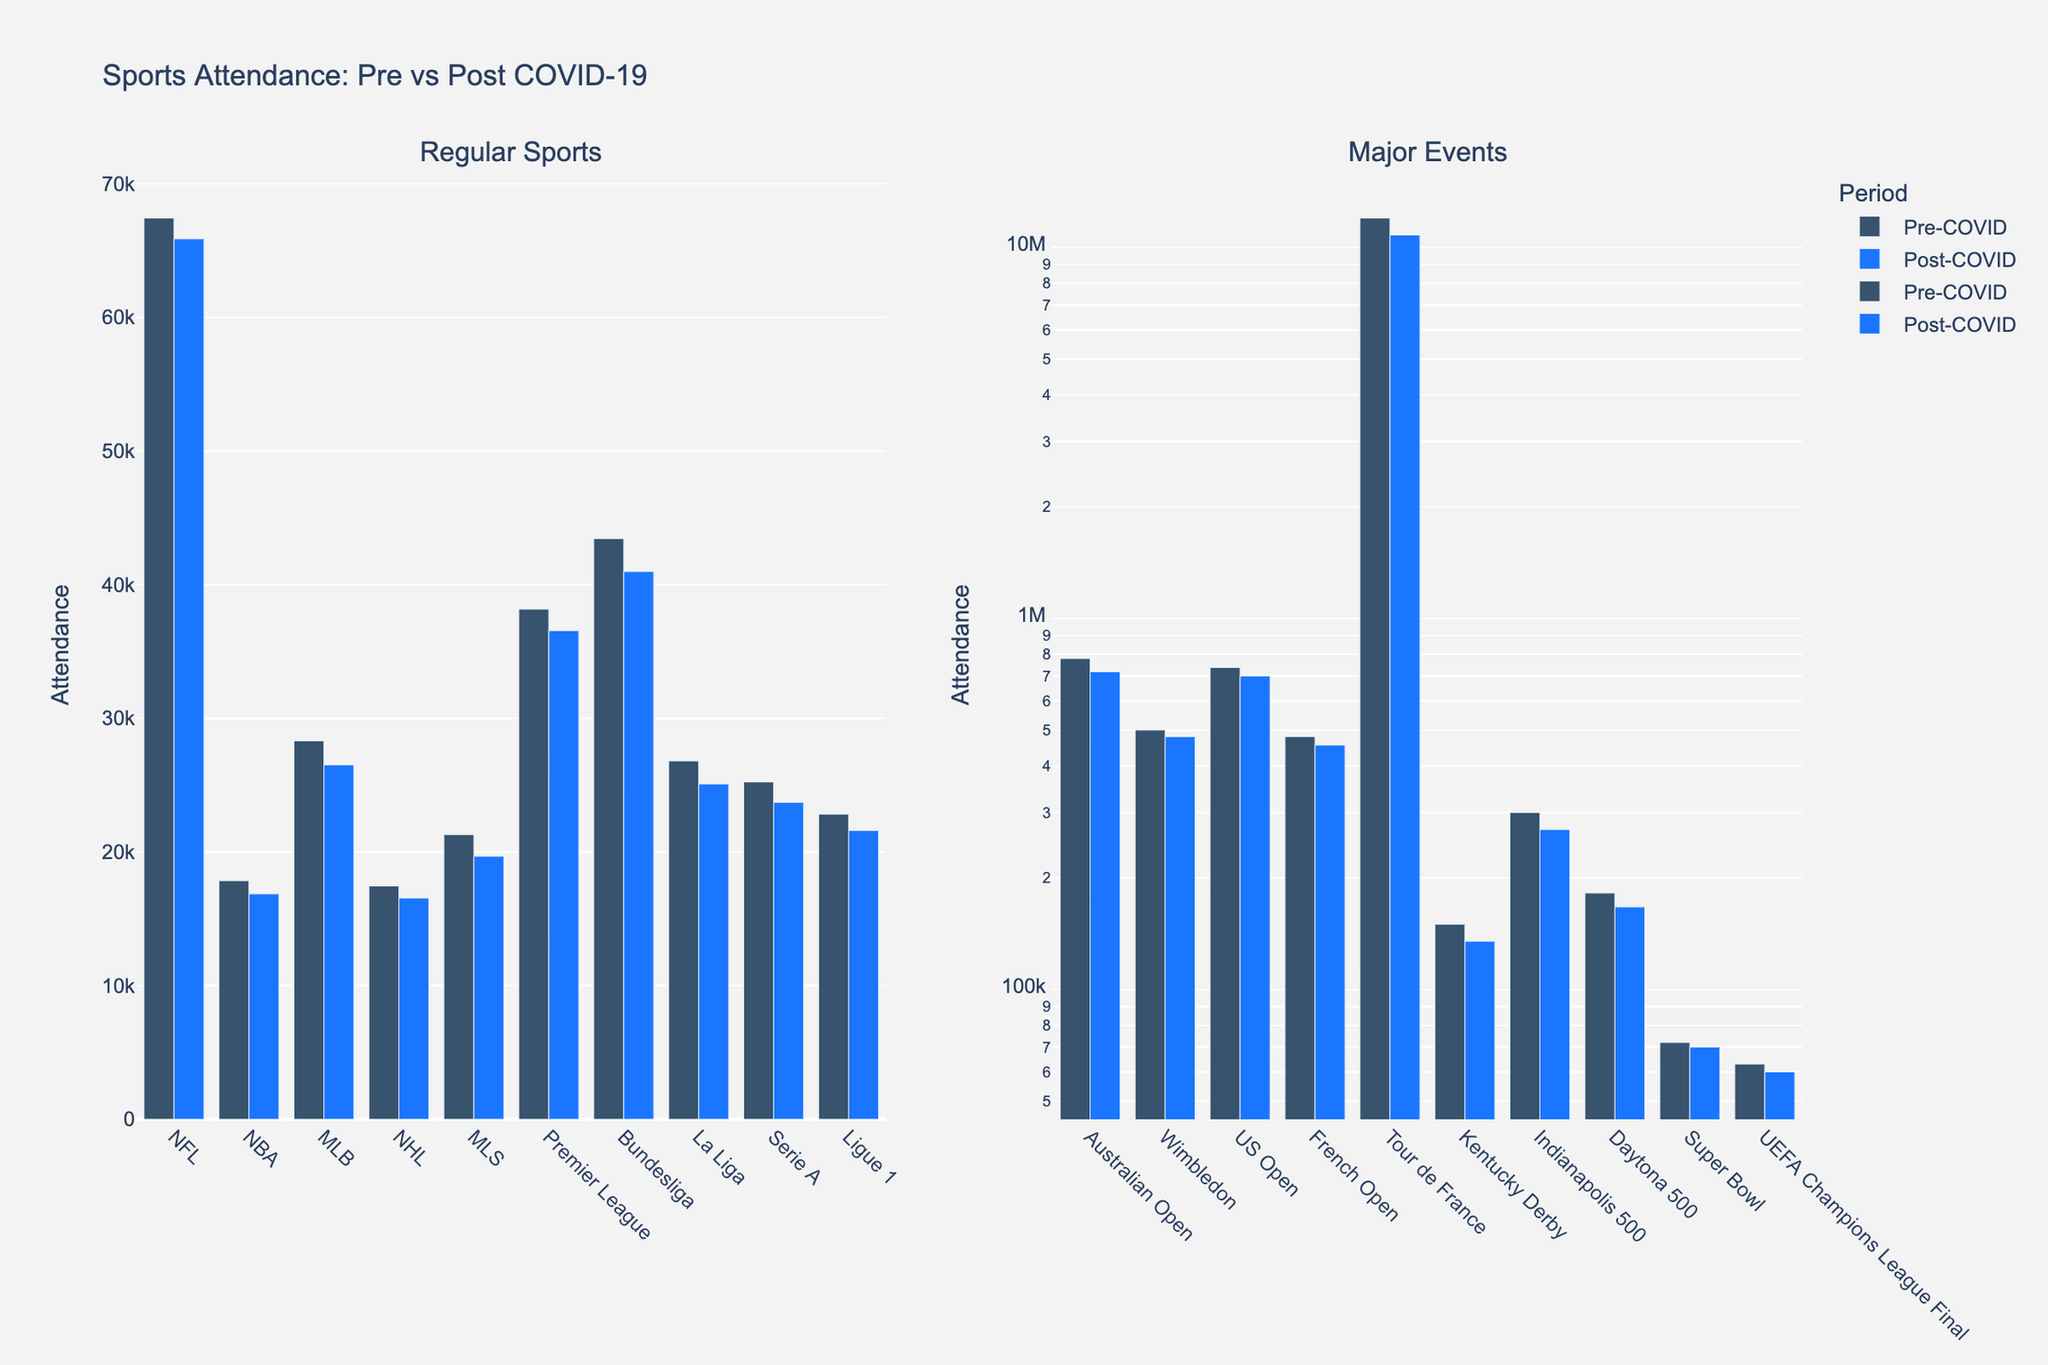Which sport saw the largest drop in attendance from Pre-COVID to Post-COVID within regular sports? To determine this, you compare the differences in attendance for each of the regular sports. The largest drop is calculated by subtracting the Post-COVID attendance from the Pre-COVID attendance and then finding the maximum value.
Answer: MLB What is the average attendance for the major events Pre-COVID? Add up all the Pre-COVID attendance numbers for the major events and divide by the number of events (there are 10 major events listed).
Answer: 1,701,778 Which sport has a smaller post-COVID attendance than its pre-COVID attendance among the major events? To answer this, you compare the Pre-COVID and Post-COVID attendance for each sport in the major events. Most of the sports in the major events have lower attendance post-COVID.
Answer: All major events Which sport experienced the smallest decrease in attendance due to COVID-19 among regular sports? Calculate the differences in attendance between Pre-COVID and Post-COVID for each regular sport and find the minimum value.
Answer: NFL How do the visual heights of the bars compare between the events with the highest attendance Pre-COVID and Post-COVID? Identify the events with the highest attendance in both periods and compare their bar heights visually. The event with the highest attendance Pre-COVID and Post-COVID is the Tour de France. Visually, the Pre-COVID bar is taller than the Post-COVID bar.
Answer: Pre-COVID bar is taller Which has a greater drop in attendance due to COVID-19: Serie A or Ligue 1? Subtract the Post-COVID attendance from the Pre-COVID attendance for both Serie A and Ligue 1, then compare the two values to see which is greater. Serie A attendance dropped from 25,237 to 23,706, and Ligue 1 attendance dropped from 22,833 to 21,609.
Answer: Serie A What is the difference in attendance between the Super Bowl and the UEFA Champions League Final Post-COVID? Subtract the UEFA Champions League Final Post-COVID attendance from the Super Bowl Post-COVID attendance. The difference is calculated as 70,000 - 60,000.
Answer: 10,000 How does the height of the NBA post-COVID attendance bar compare to the height of the NHL post-COVID attendance bar? Visually compare the heights of the bars representing the NBA and NHL Post-COVID attendance. The NBA bar is slightly taller than the NHL bar.
Answer: NBA bar is taller What is the median attendance value among major events Pre-COVID? Sort the major events' Pre-COVID attendance values in ascending order and find the median value, which is the middle value of the sorted list. There are 10 values, so the median is the average of the 5th and 6th values.
Answer: 480,575 How does the attendance drop for the Indianapolis 500 compare to that of the Daytona 500? Subtract the Post-COVID attendance from the Pre-COVID attendance for both the Indianapolis 500 and the Daytona 500, then compare the differences. Indianapolis 500 drops from 300,000 to 270,000 and Daytona 500 drops from 182,000 to 167,000.
Answer: Indianapolis 500 has a greater drop 